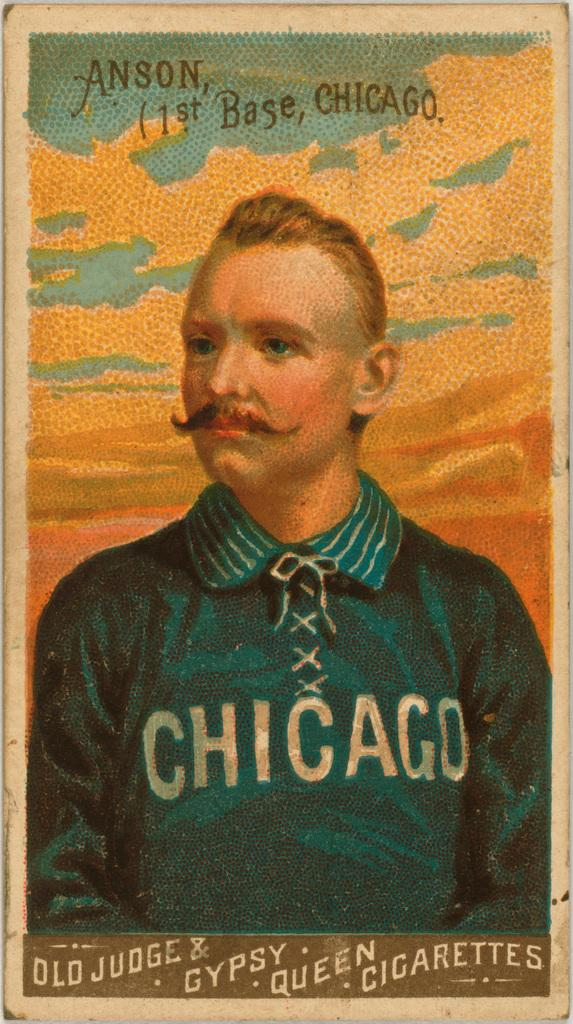Provide a one-sentence caption for the provided image. A cigarette case with a picture of a man in a Chicago shirt. 